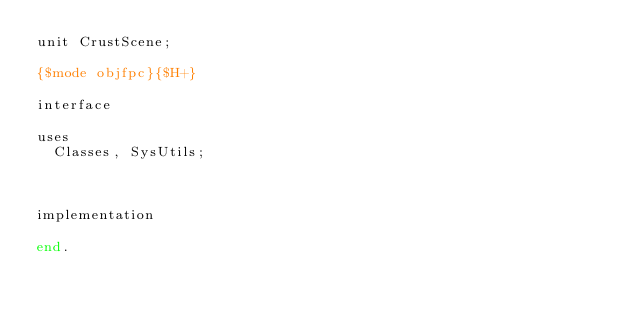Convert code to text. <code><loc_0><loc_0><loc_500><loc_500><_Pascal_>unit CrustScene;

{$mode objfpc}{$H+}

interface

uses
  Classes, SysUtils;



implementation

end.

</code> 